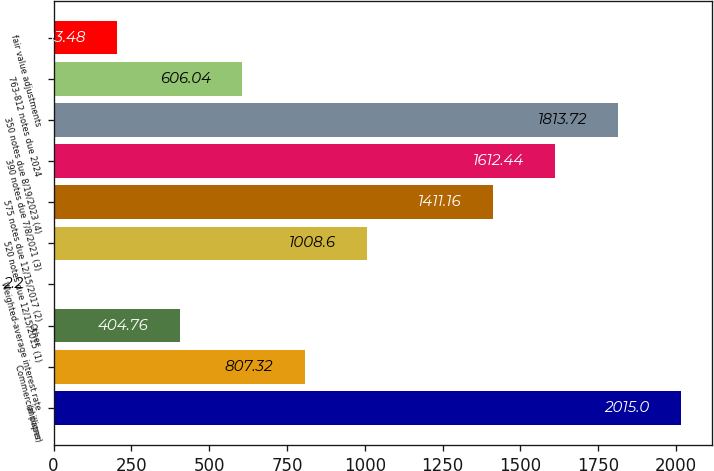Convert chart to OTSL. <chart><loc_0><loc_0><loc_500><loc_500><bar_chart><fcel>(millions)<fcel>Commercial paper<fcel>Other<fcel>Weighted-average interest rate<fcel>520 notes due 12/15/2015 (1)<fcel>575 notes due 12/15/2017 (2)<fcel>390 notes due 7/8/2021 (3)<fcel>350 notes due 8/19/2023 (4)<fcel>763-812 notes due 2024<fcel>fair value adjustments<nl><fcel>2015<fcel>807.32<fcel>404.76<fcel>2.2<fcel>1008.6<fcel>1411.16<fcel>1612.44<fcel>1813.72<fcel>606.04<fcel>203.48<nl></chart> 